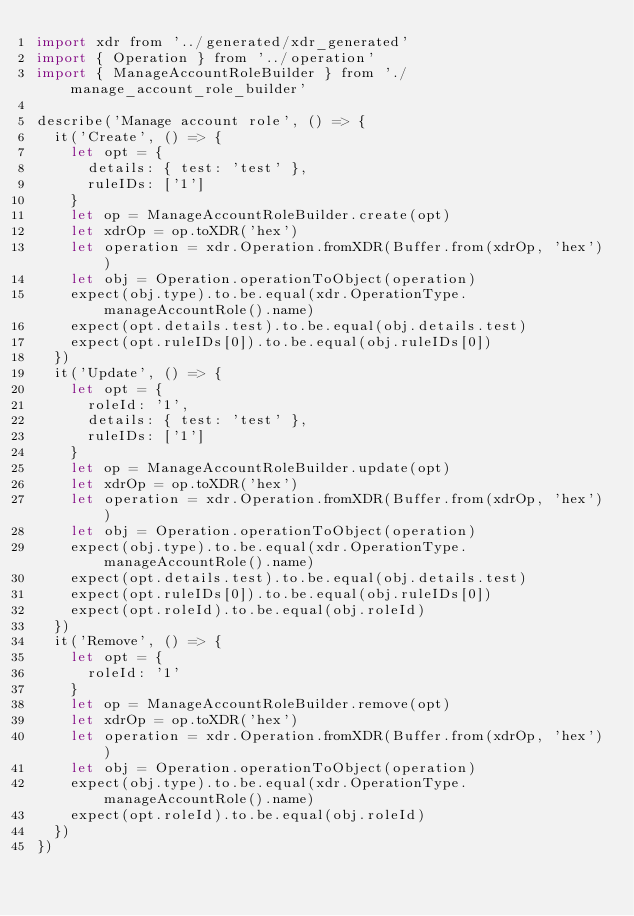<code> <loc_0><loc_0><loc_500><loc_500><_JavaScript_>import xdr from '../generated/xdr_generated'
import { Operation } from '../operation'
import { ManageAccountRoleBuilder } from './manage_account_role_builder'

describe('Manage account role', () => {
  it('Create', () => {
    let opt = {
      details: { test: 'test' },
      ruleIDs: ['1']
    }
    let op = ManageAccountRoleBuilder.create(opt)
    let xdrOp = op.toXDR('hex')
    let operation = xdr.Operation.fromXDR(Buffer.from(xdrOp, 'hex'))
    let obj = Operation.operationToObject(operation)
    expect(obj.type).to.be.equal(xdr.OperationType.manageAccountRole().name)
    expect(opt.details.test).to.be.equal(obj.details.test)
    expect(opt.ruleIDs[0]).to.be.equal(obj.ruleIDs[0])
  })
  it('Update', () => {
    let opt = {
      roleId: '1',
      details: { test: 'test' },
      ruleIDs: ['1']
    }
    let op = ManageAccountRoleBuilder.update(opt)
    let xdrOp = op.toXDR('hex')
    let operation = xdr.Operation.fromXDR(Buffer.from(xdrOp, 'hex'))
    let obj = Operation.operationToObject(operation)
    expect(obj.type).to.be.equal(xdr.OperationType.manageAccountRole().name)
    expect(opt.details.test).to.be.equal(obj.details.test)
    expect(opt.ruleIDs[0]).to.be.equal(obj.ruleIDs[0])
    expect(opt.roleId).to.be.equal(obj.roleId)
  })
  it('Remove', () => {
    let opt = {
      roleId: '1'
    }
    let op = ManageAccountRoleBuilder.remove(opt)
    let xdrOp = op.toXDR('hex')
    let operation = xdr.Operation.fromXDR(Buffer.from(xdrOp, 'hex'))
    let obj = Operation.operationToObject(operation)
    expect(obj.type).to.be.equal(xdr.OperationType.manageAccountRole().name)
    expect(opt.roleId).to.be.equal(obj.roleId)
  })
})
</code> 